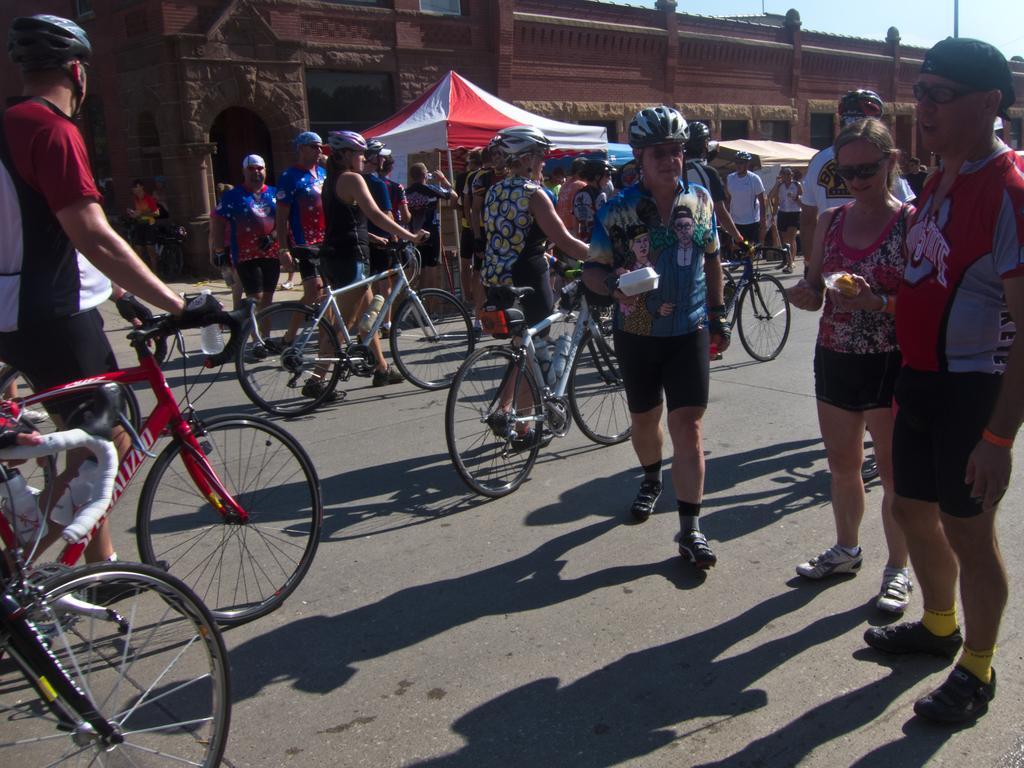Please provide a concise description of this image. In the right side a man is standing he wore a red color t-shirt. Beside him there is a girl, who is also standing, in the left side few people are walking with the cycles. In the middle it's a stone wall. There is an umbrella 